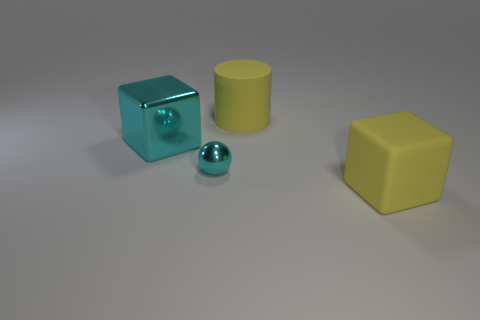Subtract all red cylinders. Subtract all gray spheres. How many cylinders are left? 1 Add 1 tiny gray matte things. How many objects exist? 5 Subtract all spheres. How many objects are left? 3 Add 2 big matte cylinders. How many big matte cylinders exist? 3 Subtract 0 purple balls. How many objects are left? 4 Subtract all tiny things. Subtract all yellow rubber cubes. How many objects are left? 2 Add 3 small metal balls. How many small metal balls are left? 4 